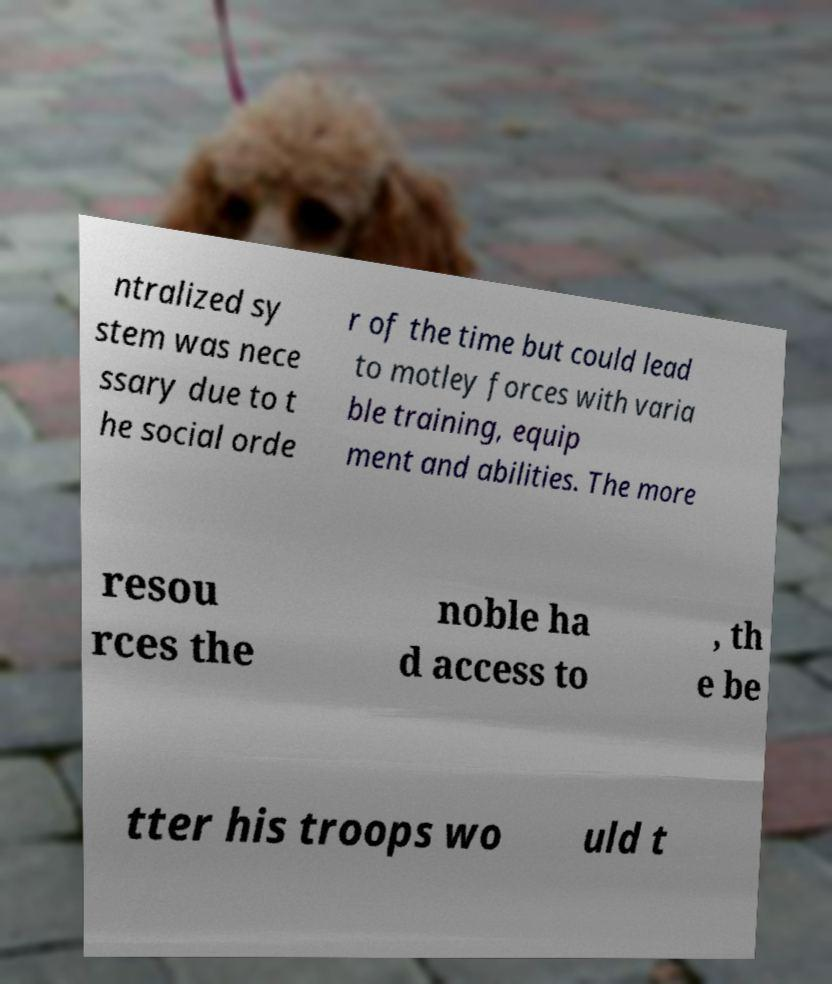Can you accurately transcribe the text from the provided image for me? ntralized sy stem was nece ssary due to t he social orde r of the time but could lead to motley forces with varia ble training, equip ment and abilities. The more resou rces the noble ha d access to , th e be tter his troops wo uld t 